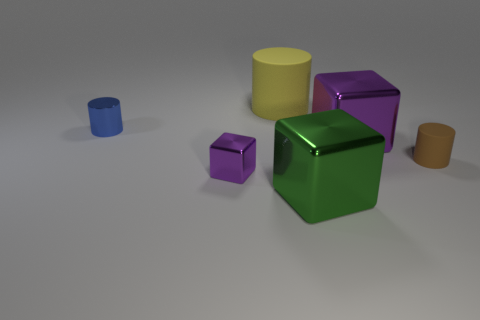What number of other small rubber things are the same shape as the yellow matte object?
Keep it short and to the point. 1. How many objects are either big blue metallic blocks or small metallic things behind the brown rubber cylinder?
Your answer should be compact. 1. There is a small metal block; is it the same color as the shiny block that is to the right of the large green thing?
Ensure brevity in your answer.  Yes. How big is the shiny thing that is on the left side of the green shiny object and to the right of the small blue metallic cylinder?
Your answer should be very brief. Small. There is a tiny purple block; are there any big objects in front of it?
Provide a short and direct response. Yes. Is there a cube that is left of the big cube in front of the brown cylinder?
Your response must be concise. Yes. Is the number of purple metal objects to the right of the blue metal cylinder the same as the number of large blocks on the right side of the tiny brown cylinder?
Your answer should be very brief. No. What color is the other tiny object that is made of the same material as the blue object?
Ensure brevity in your answer.  Purple. Are there any other blue cylinders made of the same material as the blue cylinder?
Keep it short and to the point. No. What number of things are either large purple objects or blue cylinders?
Your answer should be compact. 2. 